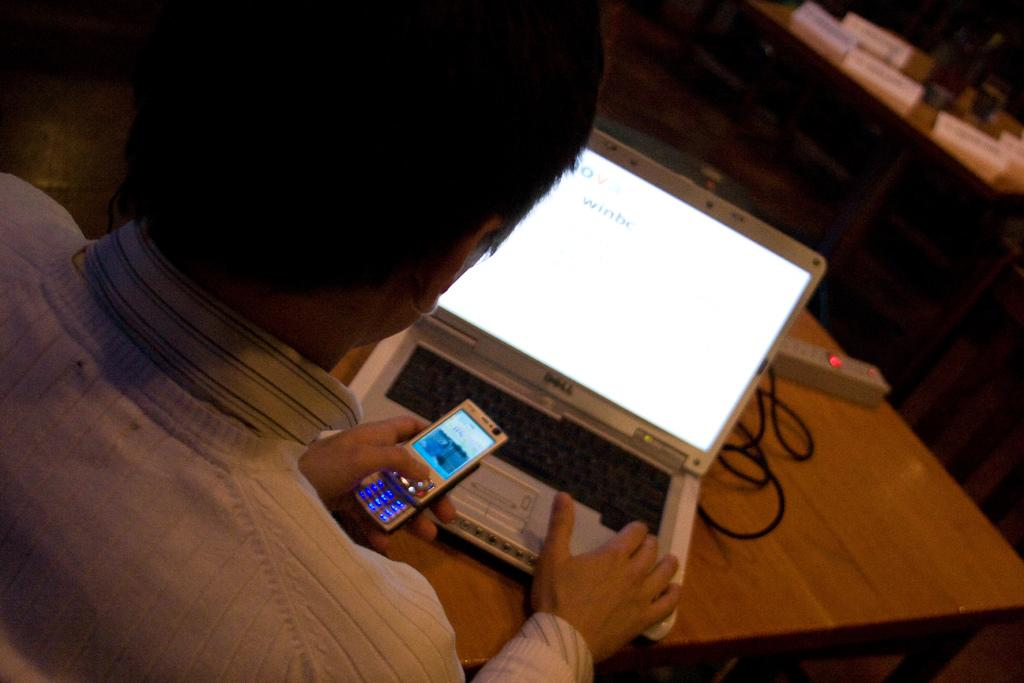<image>
Summarize the visual content of the image. A person is using a computer that is open to a page that says winbe 